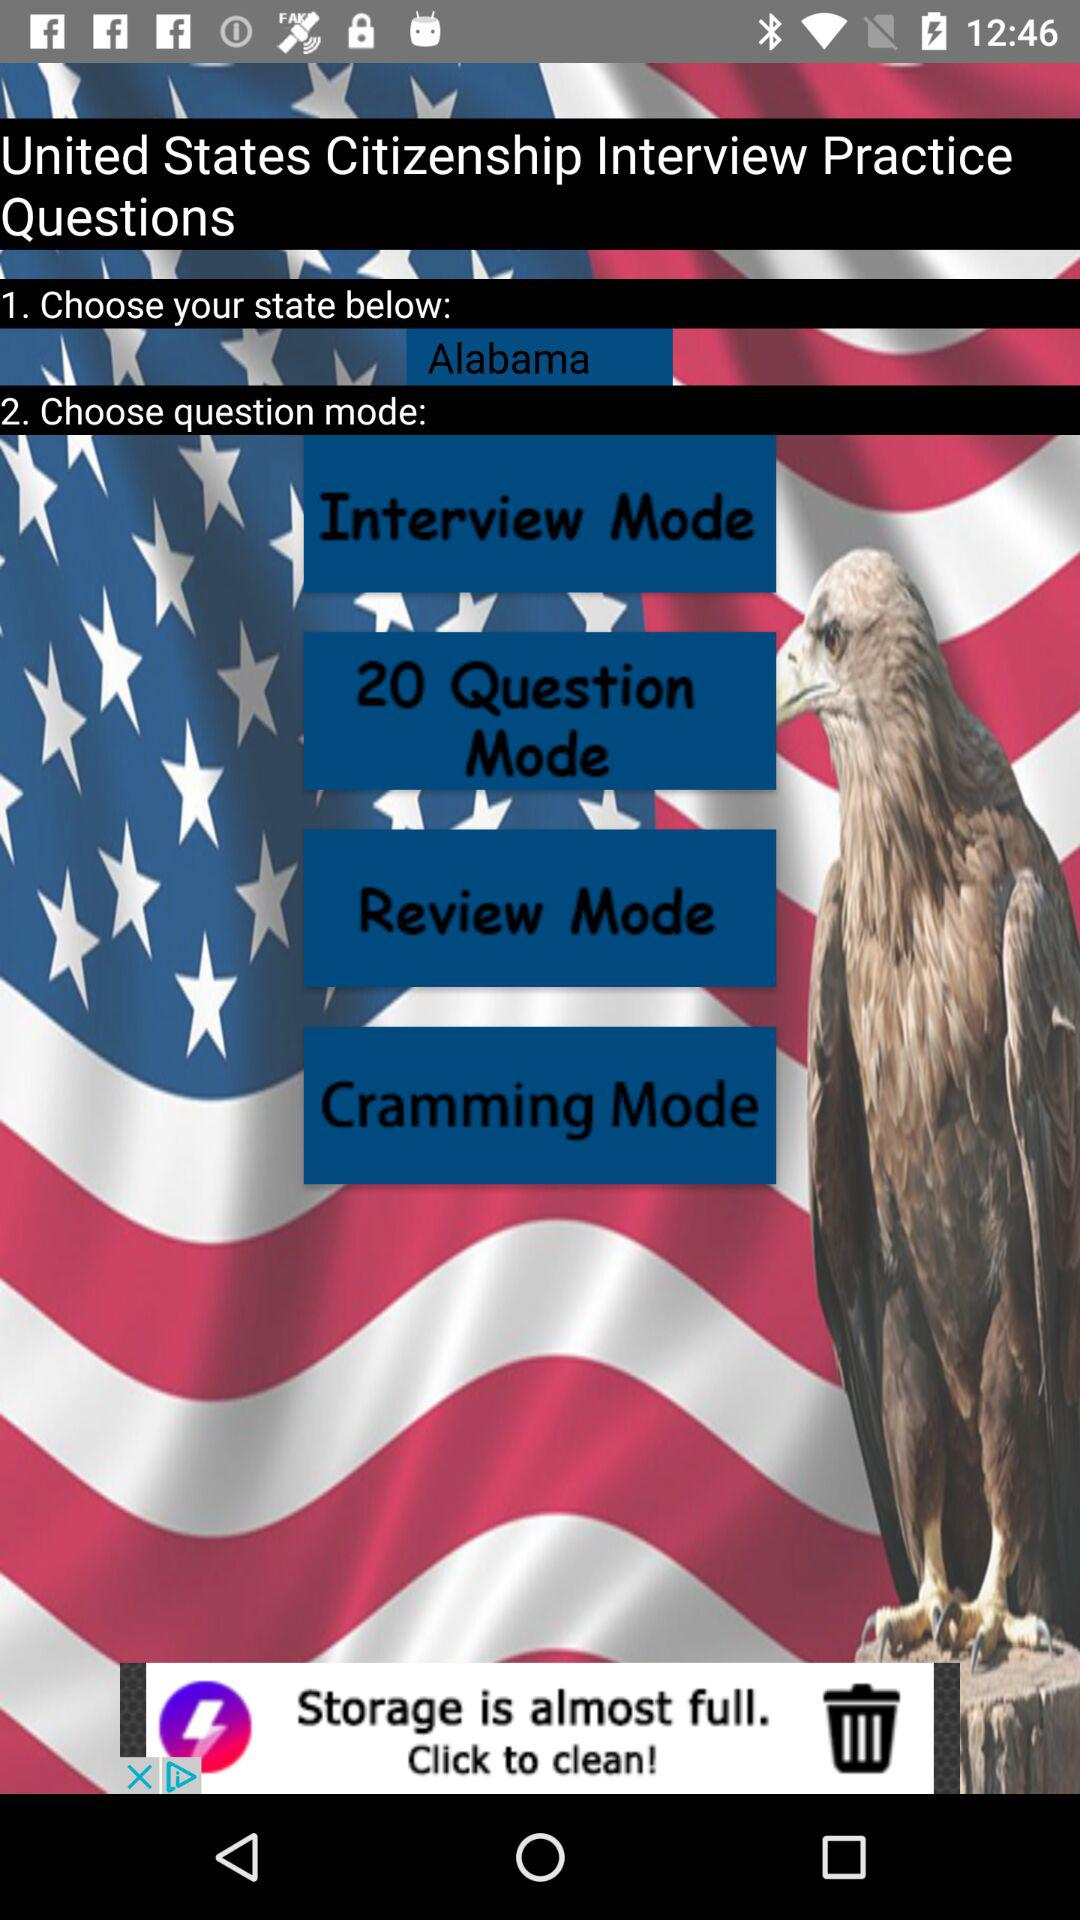How many question modes are there?
Answer the question using a single word or phrase. 4 